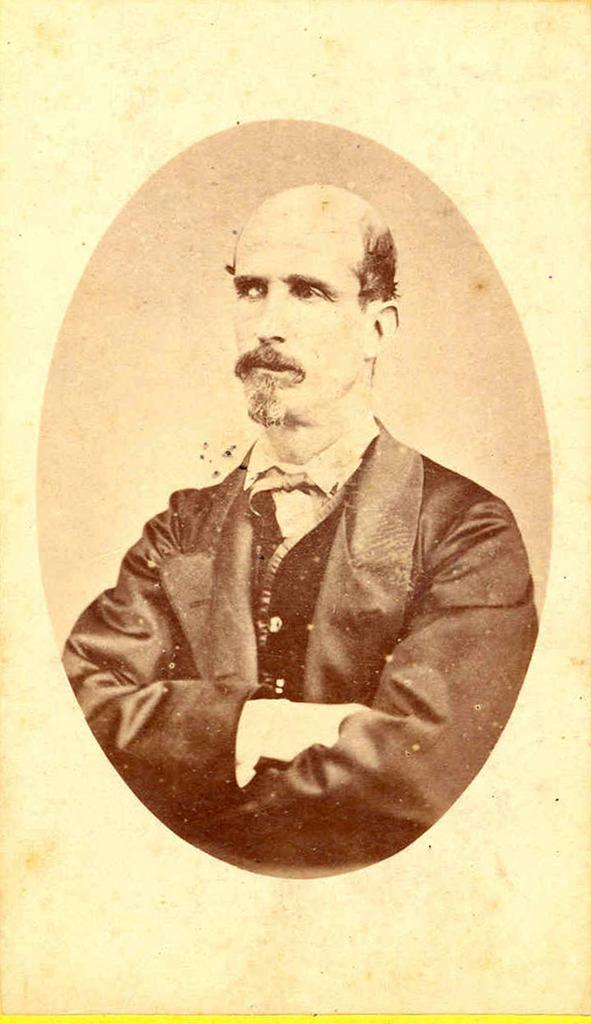What type of banana is being used as a wrench to tighten the sugar container in the image? There is no image provided, and therefore no such scene can be observed. 